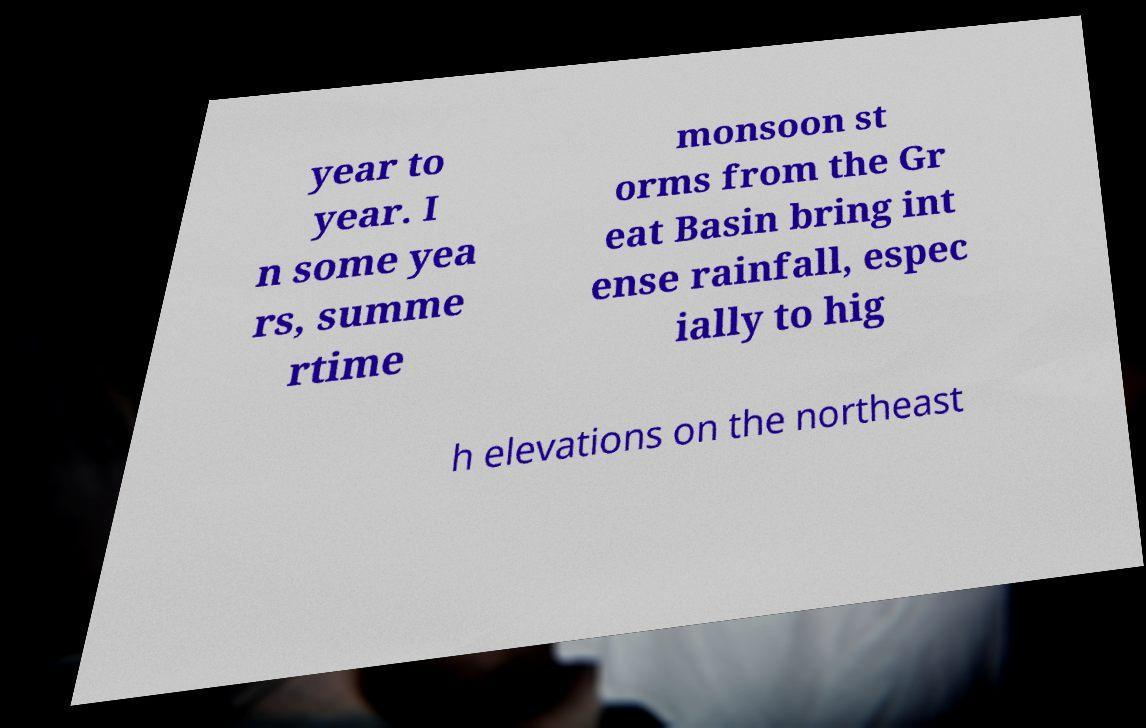Please read and relay the text visible in this image. What does it say? year to year. I n some yea rs, summe rtime monsoon st orms from the Gr eat Basin bring int ense rainfall, espec ially to hig h elevations on the northeast 